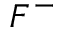<formula> <loc_0><loc_0><loc_500><loc_500>F ^ { - }</formula> 